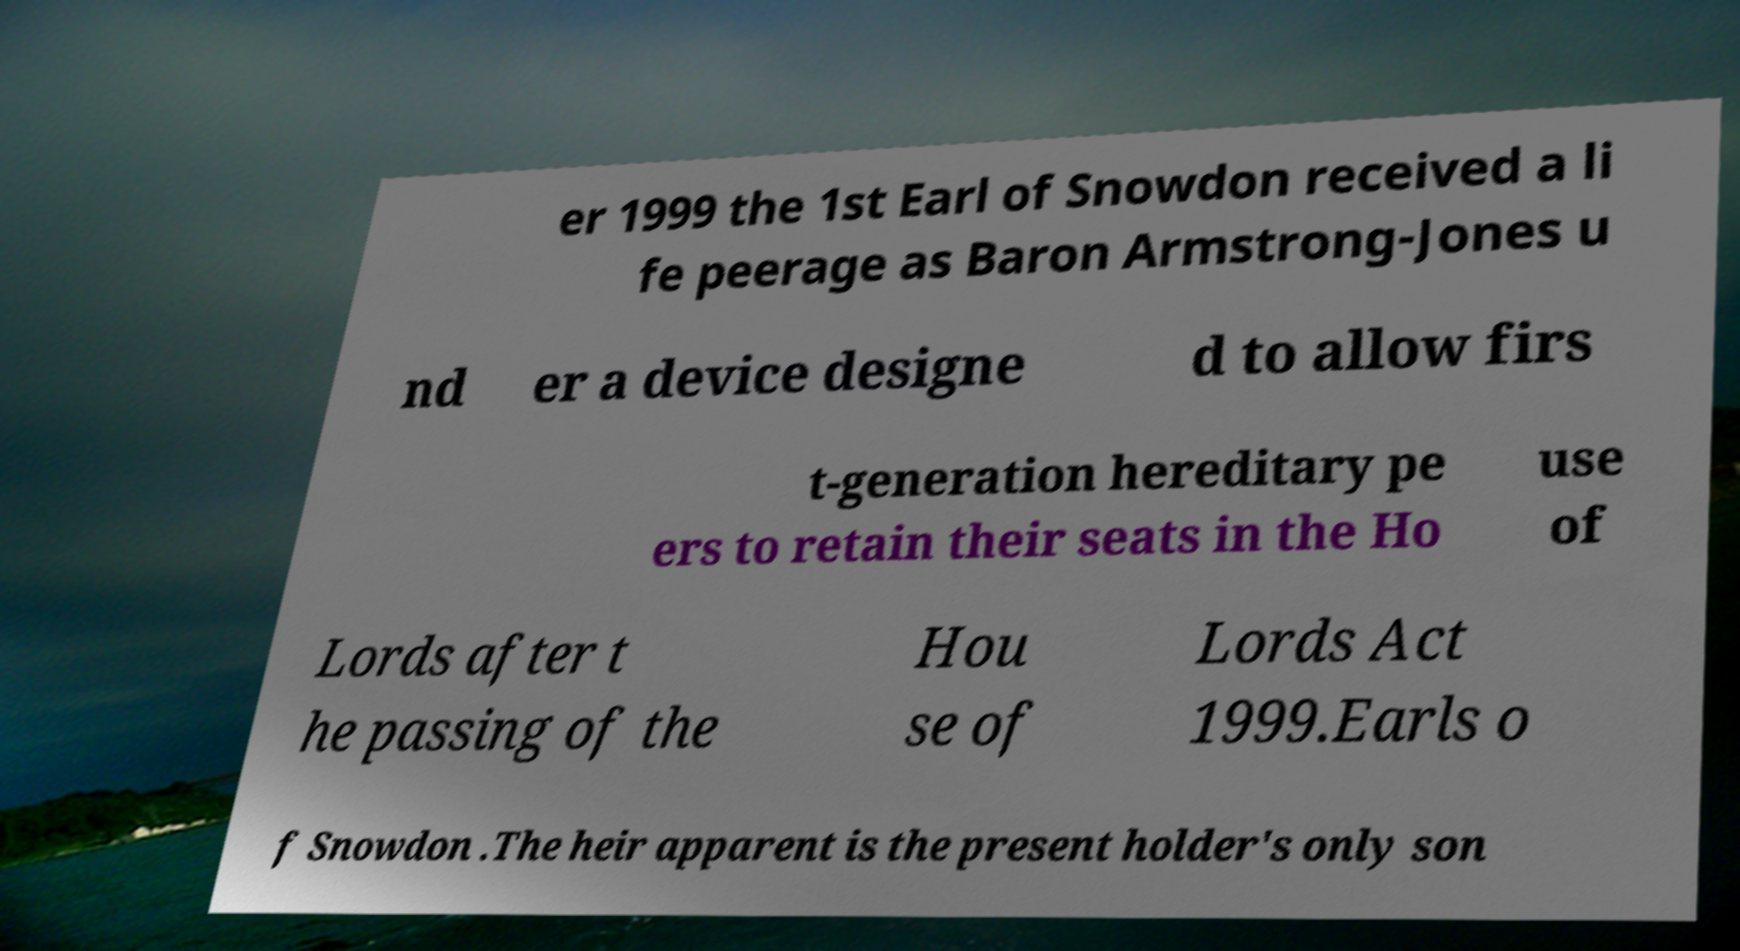Please identify and transcribe the text found in this image. er 1999 the 1st Earl of Snowdon received a li fe peerage as Baron Armstrong-Jones u nd er a device designe d to allow firs t-generation hereditary pe ers to retain their seats in the Ho use of Lords after t he passing of the Hou se of Lords Act 1999.Earls o f Snowdon .The heir apparent is the present holder's only son 